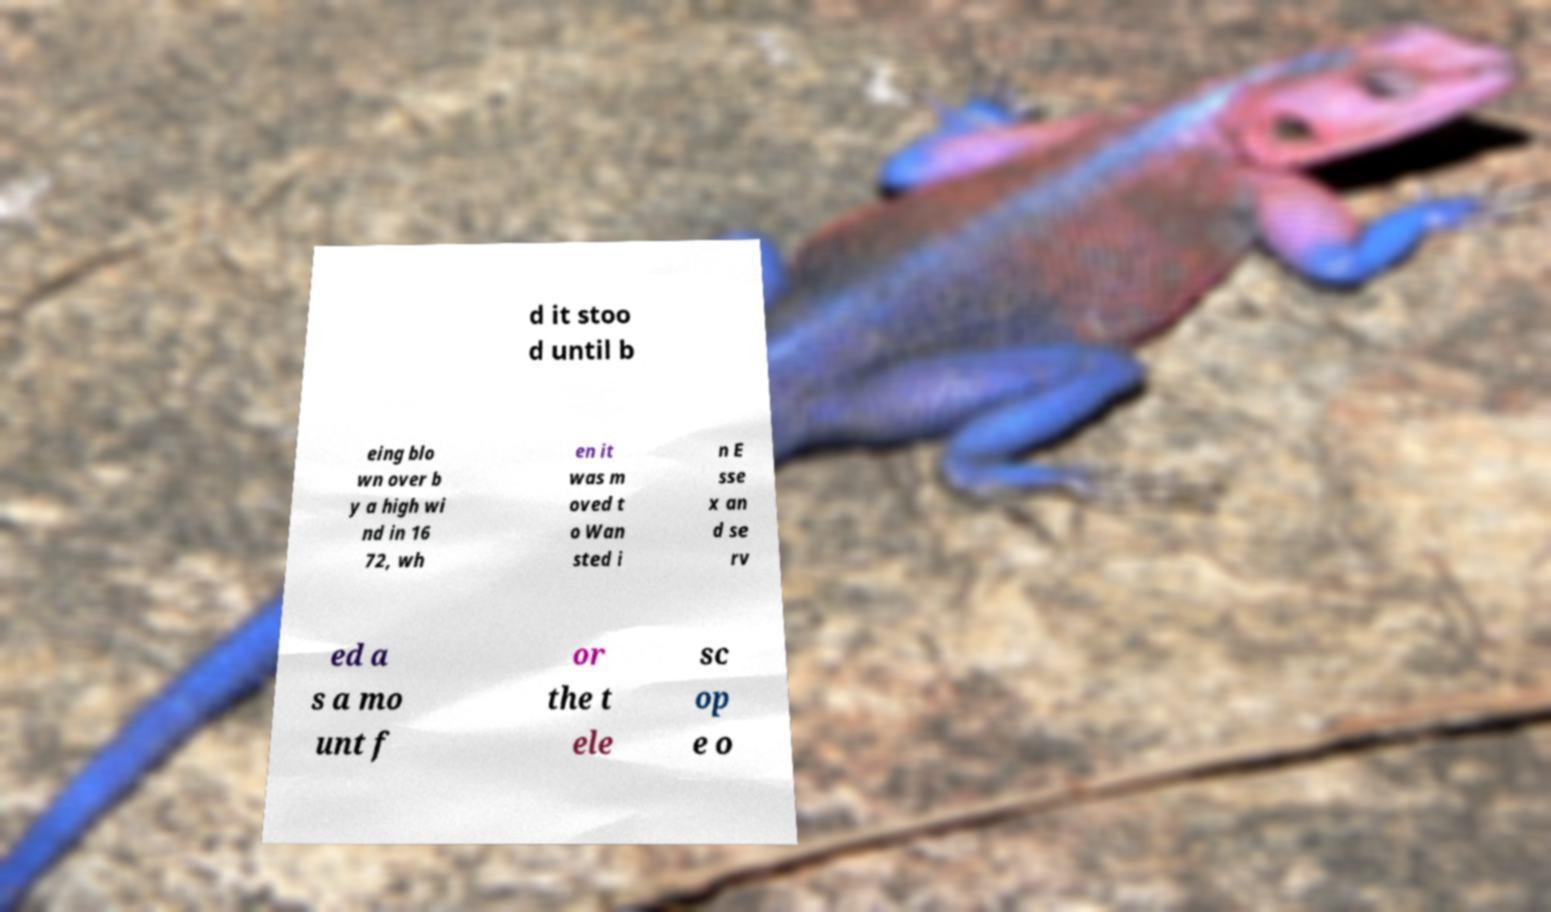For documentation purposes, I need the text within this image transcribed. Could you provide that? d it stoo d until b eing blo wn over b y a high wi nd in 16 72, wh en it was m oved t o Wan sted i n E sse x an d se rv ed a s a mo unt f or the t ele sc op e o 